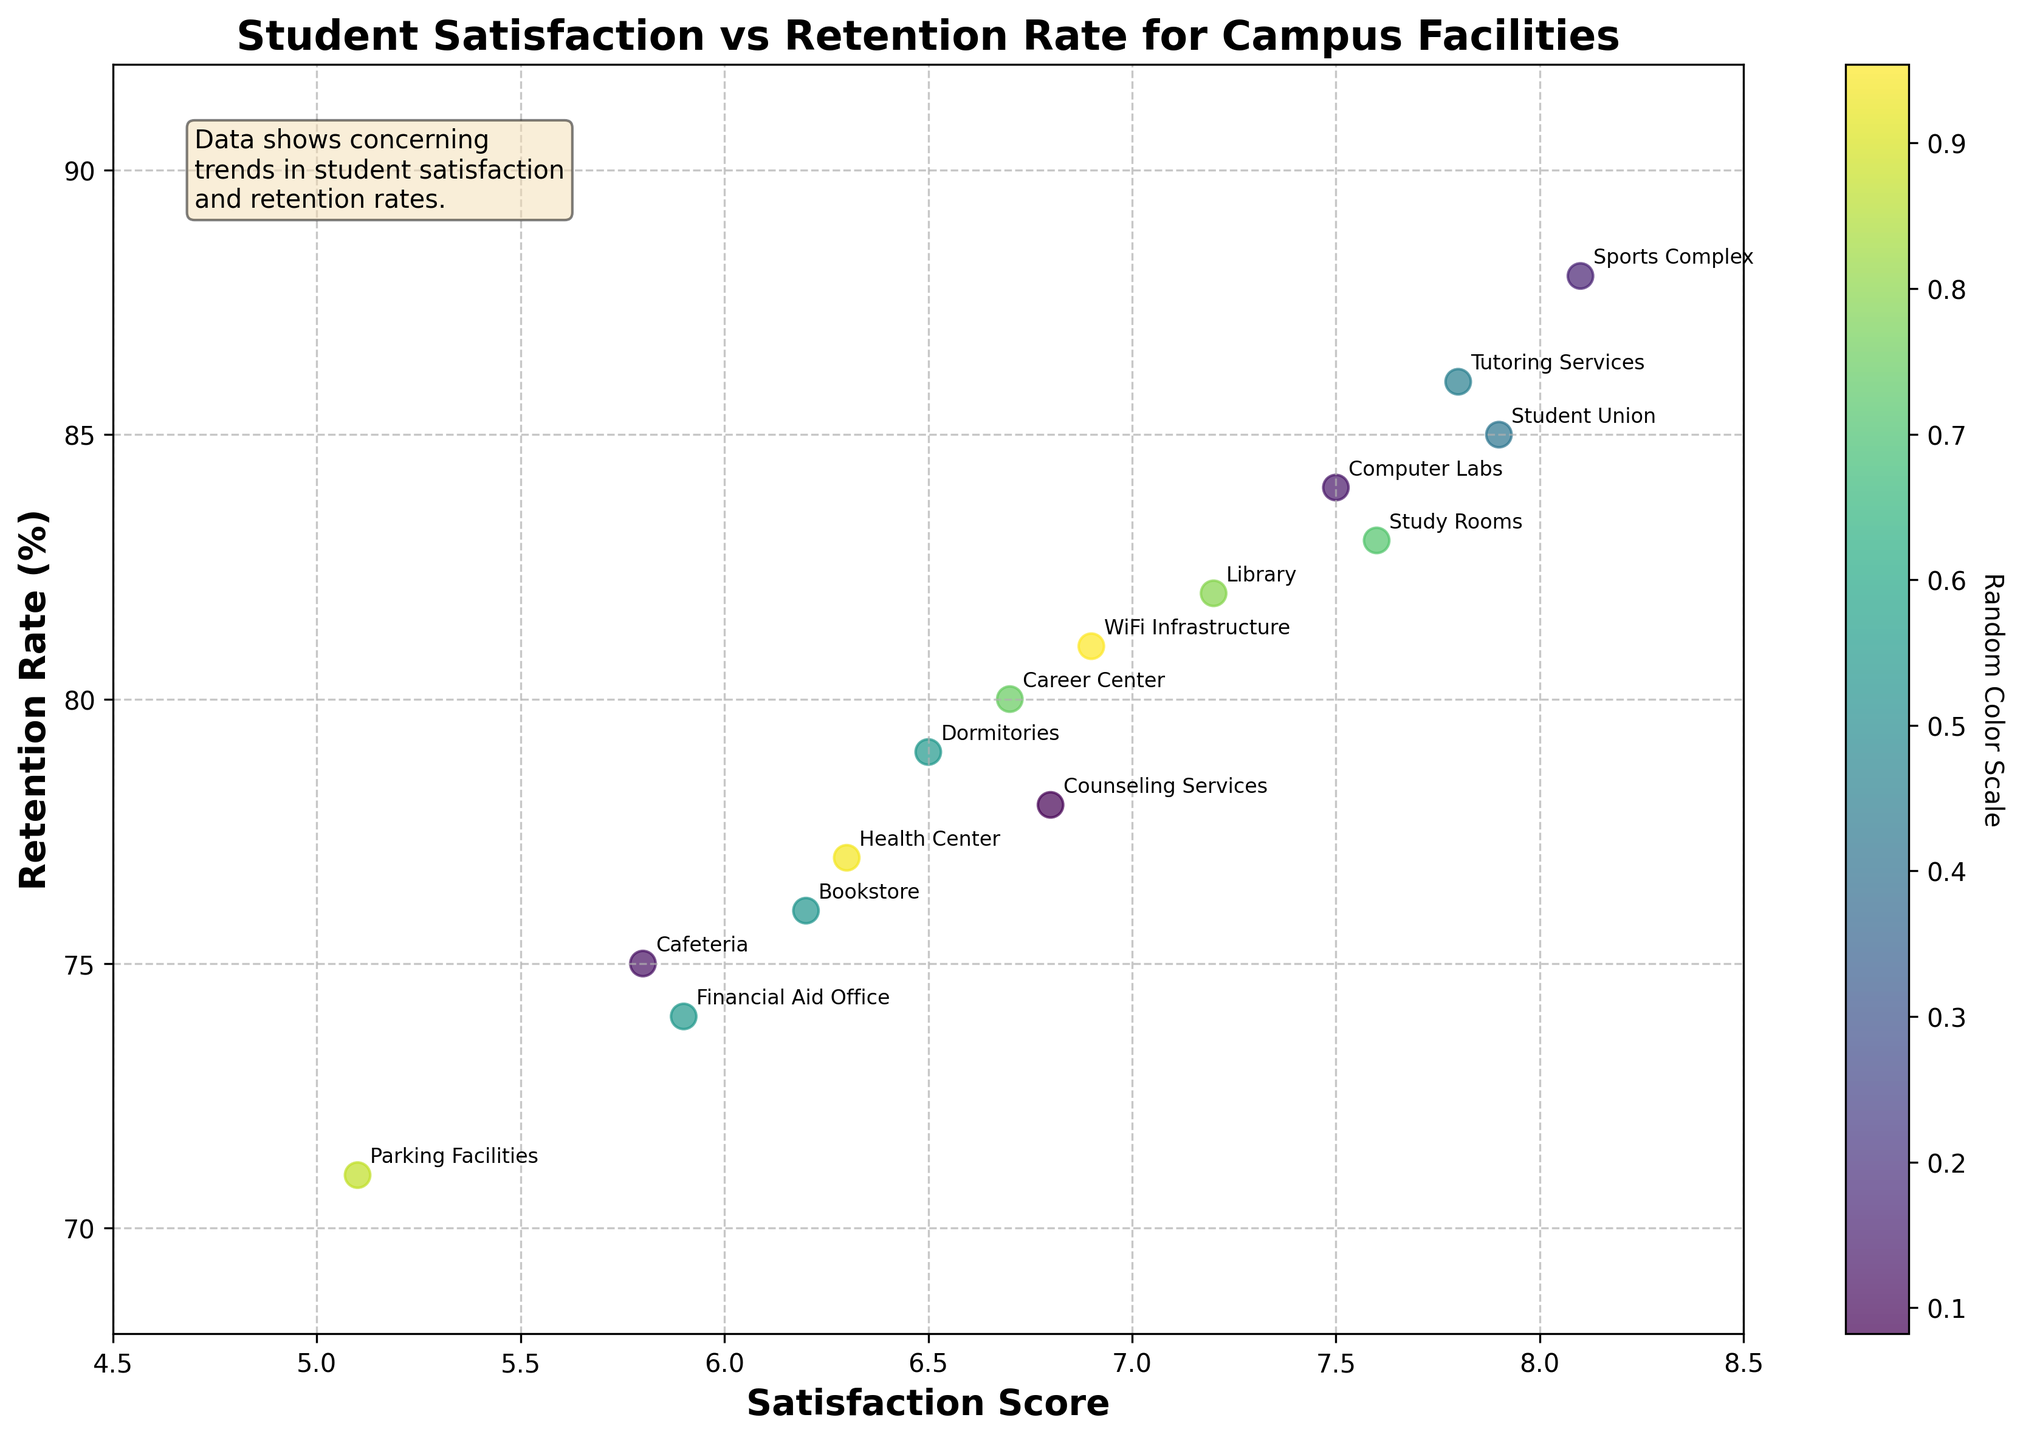What is the title of the figure? The title is displayed prominently at the top of the figure. It reads "Student Satisfaction vs Retention Rate for Campus Facilities."
Answer: Student Satisfaction vs Retention Rate for Campus Facilities Which facility has the highest retention rate and what is its satisfaction score? Locate the facility with the highest retention rate on the y-axis. The "Sports Complex" has the highest retention rate at 88%, and its satisfaction score on the x-axis is 8.1.
Answer: Sports Complex, 8.1 How many facilities have a satisfaction score below 6.0? Check the x-axis for scores below 6.0 and count the corresponding data points. The facilities are Cafeteria, Parking Facilities, Financial Aid Office, and Bookstore, totaling 4 facilities.
Answer: 4 How does the retention rate of the Library compare to that of the Cafeteria? Locate both the Library and Cafeteria on the plot. The Library has a retention rate of 82%, while the Cafeteria has a retention rate of 75%. The Library's rate is higher.
Answer: The Library has a higher retention rate than the Cafeteria What is the average satisfaction score of facilities with retention rates above 85%? Identify facilities with retention rates above 85%: Sports Complex (8.1), Student Union (7.9), and Tutoring Services (7.8). Calculate their average satisfaction score: (8.1+7.9+7.8)/3 ≈ 7.93.
Answer: 7.93 Which facility shows the lowest satisfaction score and what is its retention rate? Locate the lowest point on the x-axis. The "Parking Facilities" has the lowest satisfaction score of 5.1, and its retention rate is 71%.
Answer: Parking Facilities, 71% Are there any facilities with the same retention rate but different satisfaction scores? Look for retention rates that have more than one corresponding satisfaction score. The retention rate of 77% corresponds to both the Health Center (6.3) and Counseling Services (6.8).
Answer: Health Center and Counseling Services Which facility with a satisfaction score above 7.5 has the lowest retention rate? Identify facilities with a satisfaction score above 7.5 and find the lowest retention rate among them. "Study Rooms" has a retention rate of 83%.
Answer: Study Rooms, 83% Is there a positive correlation between student satisfaction scores and retention rates? Observing the scatter plot, most points show higher satisfaction scores corresponding to higher retention rates, indicating a general positive trend.
Answer: Yes How does the satisfaction score of the Career Center compare to the average satisfaction score of all facilities? Calculate the average satisfaction score of all facilities: (sum of all scores)/15. The sum is 102.3, so the average is 102.3/15 = 6.82. Compare it to the Career Center's score of 6.7.
Answer: The Career Center's satisfaction score is slightly below the average 